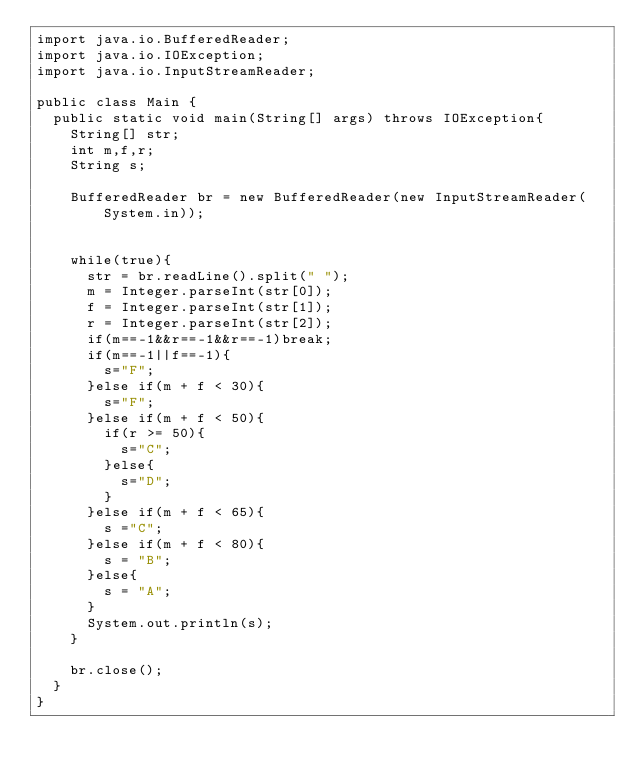<code> <loc_0><loc_0><loc_500><loc_500><_Java_>import java.io.BufferedReader;
import java.io.IOException;
import java.io.InputStreamReader;

public class Main {
	public static void main(String[] args) throws IOException{
		String[] str;
		int m,f,r;
		String s;

		BufferedReader br = new BufferedReader(new InputStreamReader(System.in));


		while(true){
			str = br.readLine().split(" ");
			m = Integer.parseInt(str[0]);
			f = Integer.parseInt(str[1]);
			r = Integer.parseInt(str[2]);
			if(m==-1&&r==-1&&r==-1)break;
			if(m==-1||f==-1){
				s="F";
			}else if(m + f < 30){
				s="F";
			}else if(m + f < 50){
				if(r >= 50){
					s="C";
				}else{
					s="D";
				}
			}else if(m + f < 65){
				s ="C";
			}else if(m + f < 80){
				s = "B";
			}else{
				s = "A";
			}
			System.out.println(s);
		}

		br.close();
	}
}</code> 